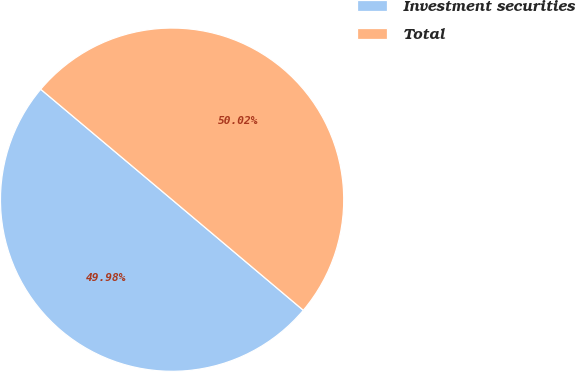<chart> <loc_0><loc_0><loc_500><loc_500><pie_chart><fcel>Investment securities<fcel>Total<nl><fcel>49.98%<fcel>50.02%<nl></chart> 